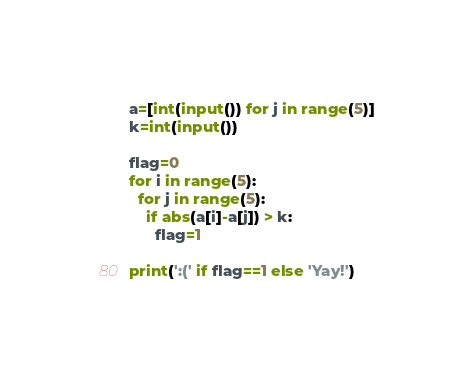Convert code to text. <code><loc_0><loc_0><loc_500><loc_500><_Python_>a=[int(input()) for j in range(5)]
k=int(input())

flag=0
for i in range(5):
  for j in range(5):
    if abs(a[i]-a[j]) > k:
      flag=1

print(':(' if flag==1 else 'Yay!')</code> 